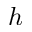<formula> <loc_0><loc_0><loc_500><loc_500>h</formula> 